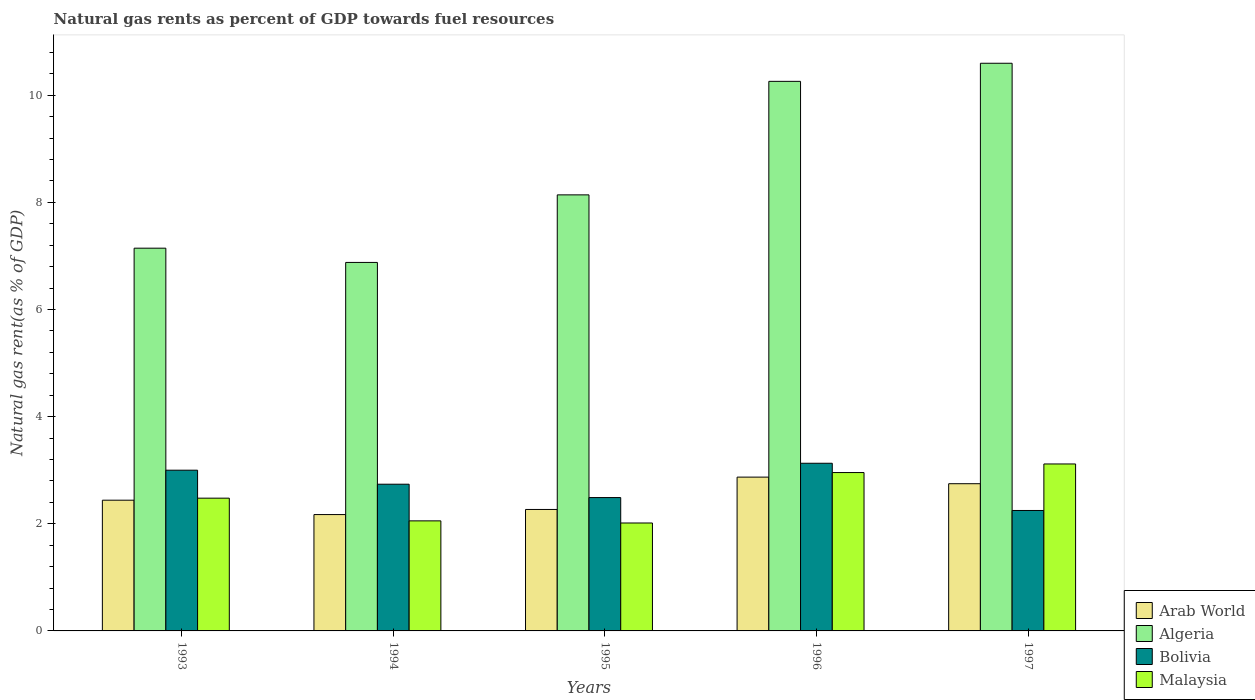How many bars are there on the 1st tick from the right?
Your answer should be very brief. 4. In how many cases, is the number of bars for a given year not equal to the number of legend labels?
Provide a succinct answer. 0. What is the natural gas rent in Arab World in 1996?
Keep it short and to the point. 2.87. Across all years, what is the maximum natural gas rent in Arab World?
Ensure brevity in your answer.  2.87. Across all years, what is the minimum natural gas rent in Algeria?
Your answer should be very brief. 6.88. In which year was the natural gas rent in Malaysia maximum?
Your response must be concise. 1997. In which year was the natural gas rent in Arab World minimum?
Your response must be concise. 1994. What is the total natural gas rent in Algeria in the graph?
Keep it short and to the point. 43.02. What is the difference between the natural gas rent in Arab World in 1993 and that in 1996?
Ensure brevity in your answer.  -0.43. What is the difference between the natural gas rent in Algeria in 1993 and the natural gas rent in Arab World in 1997?
Ensure brevity in your answer.  4.4. What is the average natural gas rent in Arab World per year?
Your answer should be very brief. 2.5. In the year 1996, what is the difference between the natural gas rent in Arab World and natural gas rent in Malaysia?
Your answer should be compact. -0.09. In how many years, is the natural gas rent in Malaysia greater than 4 %?
Your answer should be compact. 0. What is the ratio of the natural gas rent in Bolivia in 1994 to that in 1995?
Your answer should be very brief. 1.1. Is the natural gas rent in Malaysia in 1994 less than that in 1996?
Ensure brevity in your answer.  Yes. What is the difference between the highest and the second highest natural gas rent in Malaysia?
Your answer should be compact. 0.16. What is the difference between the highest and the lowest natural gas rent in Algeria?
Give a very brief answer. 3.72. In how many years, is the natural gas rent in Algeria greater than the average natural gas rent in Algeria taken over all years?
Your answer should be very brief. 2. Is the sum of the natural gas rent in Malaysia in 1995 and 1996 greater than the maximum natural gas rent in Algeria across all years?
Give a very brief answer. No. What does the 2nd bar from the right in 1995 represents?
Offer a very short reply. Bolivia. Is it the case that in every year, the sum of the natural gas rent in Bolivia and natural gas rent in Algeria is greater than the natural gas rent in Arab World?
Offer a very short reply. Yes. How many bars are there?
Offer a terse response. 20. How many years are there in the graph?
Keep it short and to the point. 5. Are the values on the major ticks of Y-axis written in scientific E-notation?
Offer a very short reply. No. Does the graph contain any zero values?
Ensure brevity in your answer.  No. Does the graph contain grids?
Provide a short and direct response. No. How are the legend labels stacked?
Your answer should be compact. Vertical. What is the title of the graph?
Give a very brief answer. Natural gas rents as percent of GDP towards fuel resources. Does "South Sudan" appear as one of the legend labels in the graph?
Ensure brevity in your answer.  No. What is the label or title of the X-axis?
Keep it short and to the point. Years. What is the label or title of the Y-axis?
Make the answer very short. Natural gas rent(as % of GDP). What is the Natural gas rent(as % of GDP) of Arab World in 1993?
Offer a terse response. 2.44. What is the Natural gas rent(as % of GDP) in Algeria in 1993?
Your answer should be compact. 7.15. What is the Natural gas rent(as % of GDP) of Bolivia in 1993?
Give a very brief answer. 3. What is the Natural gas rent(as % of GDP) of Malaysia in 1993?
Your response must be concise. 2.48. What is the Natural gas rent(as % of GDP) in Arab World in 1994?
Ensure brevity in your answer.  2.17. What is the Natural gas rent(as % of GDP) of Algeria in 1994?
Offer a terse response. 6.88. What is the Natural gas rent(as % of GDP) in Bolivia in 1994?
Your response must be concise. 2.74. What is the Natural gas rent(as % of GDP) of Malaysia in 1994?
Offer a very short reply. 2.05. What is the Natural gas rent(as % of GDP) in Arab World in 1995?
Ensure brevity in your answer.  2.27. What is the Natural gas rent(as % of GDP) of Algeria in 1995?
Your answer should be very brief. 8.14. What is the Natural gas rent(as % of GDP) of Bolivia in 1995?
Offer a terse response. 2.49. What is the Natural gas rent(as % of GDP) in Malaysia in 1995?
Your answer should be compact. 2.01. What is the Natural gas rent(as % of GDP) of Arab World in 1996?
Ensure brevity in your answer.  2.87. What is the Natural gas rent(as % of GDP) of Algeria in 1996?
Ensure brevity in your answer.  10.26. What is the Natural gas rent(as % of GDP) in Bolivia in 1996?
Offer a very short reply. 3.13. What is the Natural gas rent(as % of GDP) of Malaysia in 1996?
Offer a terse response. 2.96. What is the Natural gas rent(as % of GDP) of Arab World in 1997?
Provide a succinct answer. 2.75. What is the Natural gas rent(as % of GDP) of Algeria in 1997?
Make the answer very short. 10.6. What is the Natural gas rent(as % of GDP) of Bolivia in 1997?
Your answer should be very brief. 2.25. What is the Natural gas rent(as % of GDP) of Malaysia in 1997?
Your answer should be compact. 3.12. Across all years, what is the maximum Natural gas rent(as % of GDP) of Arab World?
Make the answer very short. 2.87. Across all years, what is the maximum Natural gas rent(as % of GDP) in Algeria?
Give a very brief answer. 10.6. Across all years, what is the maximum Natural gas rent(as % of GDP) of Bolivia?
Ensure brevity in your answer.  3.13. Across all years, what is the maximum Natural gas rent(as % of GDP) of Malaysia?
Offer a very short reply. 3.12. Across all years, what is the minimum Natural gas rent(as % of GDP) of Arab World?
Provide a succinct answer. 2.17. Across all years, what is the minimum Natural gas rent(as % of GDP) of Algeria?
Your answer should be compact. 6.88. Across all years, what is the minimum Natural gas rent(as % of GDP) in Bolivia?
Make the answer very short. 2.25. Across all years, what is the minimum Natural gas rent(as % of GDP) in Malaysia?
Give a very brief answer. 2.01. What is the total Natural gas rent(as % of GDP) in Arab World in the graph?
Ensure brevity in your answer.  12.5. What is the total Natural gas rent(as % of GDP) of Algeria in the graph?
Provide a succinct answer. 43.02. What is the total Natural gas rent(as % of GDP) in Bolivia in the graph?
Make the answer very short. 13.61. What is the total Natural gas rent(as % of GDP) of Malaysia in the graph?
Provide a succinct answer. 12.62. What is the difference between the Natural gas rent(as % of GDP) of Arab World in 1993 and that in 1994?
Your response must be concise. 0.27. What is the difference between the Natural gas rent(as % of GDP) in Algeria in 1993 and that in 1994?
Keep it short and to the point. 0.27. What is the difference between the Natural gas rent(as % of GDP) of Bolivia in 1993 and that in 1994?
Offer a terse response. 0.26. What is the difference between the Natural gas rent(as % of GDP) in Malaysia in 1993 and that in 1994?
Your response must be concise. 0.42. What is the difference between the Natural gas rent(as % of GDP) of Arab World in 1993 and that in 1995?
Provide a succinct answer. 0.17. What is the difference between the Natural gas rent(as % of GDP) in Algeria in 1993 and that in 1995?
Your answer should be very brief. -0.99. What is the difference between the Natural gas rent(as % of GDP) of Bolivia in 1993 and that in 1995?
Offer a terse response. 0.51. What is the difference between the Natural gas rent(as % of GDP) of Malaysia in 1993 and that in 1995?
Your response must be concise. 0.46. What is the difference between the Natural gas rent(as % of GDP) of Arab World in 1993 and that in 1996?
Offer a very short reply. -0.43. What is the difference between the Natural gas rent(as % of GDP) in Algeria in 1993 and that in 1996?
Make the answer very short. -3.11. What is the difference between the Natural gas rent(as % of GDP) of Bolivia in 1993 and that in 1996?
Your answer should be compact. -0.13. What is the difference between the Natural gas rent(as % of GDP) in Malaysia in 1993 and that in 1996?
Ensure brevity in your answer.  -0.48. What is the difference between the Natural gas rent(as % of GDP) of Arab World in 1993 and that in 1997?
Ensure brevity in your answer.  -0.31. What is the difference between the Natural gas rent(as % of GDP) of Algeria in 1993 and that in 1997?
Your answer should be compact. -3.45. What is the difference between the Natural gas rent(as % of GDP) of Bolivia in 1993 and that in 1997?
Make the answer very short. 0.75. What is the difference between the Natural gas rent(as % of GDP) in Malaysia in 1993 and that in 1997?
Provide a short and direct response. -0.64. What is the difference between the Natural gas rent(as % of GDP) in Arab World in 1994 and that in 1995?
Your response must be concise. -0.1. What is the difference between the Natural gas rent(as % of GDP) in Algeria in 1994 and that in 1995?
Provide a short and direct response. -1.26. What is the difference between the Natural gas rent(as % of GDP) of Bolivia in 1994 and that in 1995?
Offer a terse response. 0.25. What is the difference between the Natural gas rent(as % of GDP) in Malaysia in 1994 and that in 1995?
Provide a short and direct response. 0.04. What is the difference between the Natural gas rent(as % of GDP) in Arab World in 1994 and that in 1996?
Keep it short and to the point. -0.7. What is the difference between the Natural gas rent(as % of GDP) of Algeria in 1994 and that in 1996?
Your answer should be very brief. -3.38. What is the difference between the Natural gas rent(as % of GDP) of Bolivia in 1994 and that in 1996?
Make the answer very short. -0.39. What is the difference between the Natural gas rent(as % of GDP) of Malaysia in 1994 and that in 1996?
Your answer should be very brief. -0.9. What is the difference between the Natural gas rent(as % of GDP) of Arab World in 1994 and that in 1997?
Your answer should be compact. -0.58. What is the difference between the Natural gas rent(as % of GDP) of Algeria in 1994 and that in 1997?
Give a very brief answer. -3.72. What is the difference between the Natural gas rent(as % of GDP) of Bolivia in 1994 and that in 1997?
Your answer should be compact. 0.49. What is the difference between the Natural gas rent(as % of GDP) of Malaysia in 1994 and that in 1997?
Provide a short and direct response. -1.06. What is the difference between the Natural gas rent(as % of GDP) in Arab World in 1995 and that in 1996?
Provide a short and direct response. -0.6. What is the difference between the Natural gas rent(as % of GDP) in Algeria in 1995 and that in 1996?
Your answer should be compact. -2.12. What is the difference between the Natural gas rent(as % of GDP) in Bolivia in 1995 and that in 1996?
Keep it short and to the point. -0.64. What is the difference between the Natural gas rent(as % of GDP) of Malaysia in 1995 and that in 1996?
Ensure brevity in your answer.  -0.94. What is the difference between the Natural gas rent(as % of GDP) in Arab World in 1995 and that in 1997?
Your answer should be very brief. -0.48. What is the difference between the Natural gas rent(as % of GDP) of Algeria in 1995 and that in 1997?
Your answer should be compact. -2.46. What is the difference between the Natural gas rent(as % of GDP) in Bolivia in 1995 and that in 1997?
Your answer should be compact. 0.24. What is the difference between the Natural gas rent(as % of GDP) in Malaysia in 1995 and that in 1997?
Your answer should be compact. -1.1. What is the difference between the Natural gas rent(as % of GDP) in Arab World in 1996 and that in 1997?
Make the answer very short. 0.12. What is the difference between the Natural gas rent(as % of GDP) of Algeria in 1996 and that in 1997?
Provide a succinct answer. -0.34. What is the difference between the Natural gas rent(as % of GDP) of Bolivia in 1996 and that in 1997?
Your response must be concise. 0.88. What is the difference between the Natural gas rent(as % of GDP) of Malaysia in 1996 and that in 1997?
Offer a terse response. -0.16. What is the difference between the Natural gas rent(as % of GDP) in Arab World in 1993 and the Natural gas rent(as % of GDP) in Algeria in 1994?
Keep it short and to the point. -4.44. What is the difference between the Natural gas rent(as % of GDP) in Arab World in 1993 and the Natural gas rent(as % of GDP) in Bolivia in 1994?
Your answer should be very brief. -0.3. What is the difference between the Natural gas rent(as % of GDP) of Arab World in 1993 and the Natural gas rent(as % of GDP) of Malaysia in 1994?
Your answer should be compact. 0.39. What is the difference between the Natural gas rent(as % of GDP) of Algeria in 1993 and the Natural gas rent(as % of GDP) of Bolivia in 1994?
Offer a very short reply. 4.41. What is the difference between the Natural gas rent(as % of GDP) of Algeria in 1993 and the Natural gas rent(as % of GDP) of Malaysia in 1994?
Ensure brevity in your answer.  5.09. What is the difference between the Natural gas rent(as % of GDP) in Bolivia in 1993 and the Natural gas rent(as % of GDP) in Malaysia in 1994?
Offer a very short reply. 0.95. What is the difference between the Natural gas rent(as % of GDP) in Arab World in 1993 and the Natural gas rent(as % of GDP) in Algeria in 1995?
Your response must be concise. -5.7. What is the difference between the Natural gas rent(as % of GDP) of Arab World in 1993 and the Natural gas rent(as % of GDP) of Bolivia in 1995?
Ensure brevity in your answer.  -0.05. What is the difference between the Natural gas rent(as % of GDP) of Arab World in 1993 and the Natural gas rent(as % of GDP) of Malaysia in 1995?
Make the answer very short. 0.43. What is the difference between the Natural gas rent(as % of GDP) of Algeria in 1993 and the Natural gas rent(as % of GDP) of Bolivia in 1995?
Keep it short and to the point. 4.66. What is the difference between the Natural gas rent(as % of GDP) in Algeria in 1993 and the Natural gas rent(as % of GDP) in Malaysia in 1995?
Give a very brief answer. 5.13. What is the difference between the Natural gas rent(as % of GDP) in Bolivia in 1993 and the Natural gas rent(as % of GDP) in Malaysia in 1995?
Offer a very short reply. 0.99. What is the difference between the Natural gas rent(as % of GDP) in Arab World in 1993 and the Natural gas rent(as % of GDP) in Algeria in 1996?
Give a very brief answer. -7.82. What is the difference between the Natural gas rent(as % of GDP) of Arab World in 1993 and the Natural gas rent(as % of GDP) of Bolivia in 1996?
Give a very brief answer. -0.69. What is the difference between the Natural gas rent(as % of GDP) of Arab World in 1993 and the Natural gas rent(as % of GDP) of Malaysia in 1996?
Offer a terse response. -0.52. What is the difference between the Natural gas rent(as % of GDP) in Algeria in 1993 and the Natural gas rent(as % of GDP) in Bolivia in 1996?
Offer a terse response. 4.02. What is the difference between the Natural gas rent(as % of GDP) in Algeria in 1993 and the Natural gas rent(as % of GDP) in Malaysia in 1996?
Offer a very short reply. 4.19. What is the difference between the Natural gas rent(as % of GDP) in Bolivia in 1993 and the Natural gas rent(as % of GDP) in Malaysia in 1996?
Ensure brevity in your answer.  0.04. What is the difference between the Natural gas rent(as % of GDP) of Arab World in 1993 and the Natural gas rent(as % of GDP) of Algeria in 1997?
Make the answer very short. -8.16. What is the difference between the Natural gas rent(as % of GDP) in Arab World in 1993 and the Natural gas rent(as % of GDP) in Bolivia in 1997?
Provide a succinct answer. 0.19. What is the difference between the Natural gas rent(as % of GDP) of Arab World in 1993 and the Natural gas rent(as % of GDP) of Malaysia in 1997?
Make the answer very short. -0.68. What is the difference between the Natural gas rent(as % of GDP) in Algeria in 1993 and the Natural gas rent(as % of GDP) in Bolivia in 1997?
Keep it short and to the point. 4.9. What is the difference between the Natural gas rent(as % of GDP) of Algeria in 1993 and the Natural gas rent(as % of GDP) of Malaysia in 1997?
Keep it short and to the point. 4.03. What is the difference between the Natural gas rent(as % of GDP) of Bolivia in 1993 and the Natural gas rent(as % of GDP) of Malaysia in 1997?
Offer a terse response. -0.12. What is the difference between the Natural gas rent(as % of GDP) in Arab World in 1994 and the Natural gas rent(as % of GDP) in Algeria in 1995?
Keep it short and to the point. -5.97. What is the difference between the Natural gas rent(as % of GDP) of Arab World in 1994 and the Natural gas rent(as % of GDP) of Bolivia in 1995?
Keep it short and to the point. -0.32. What is the difference between the Natural gas rent(as % of GDP) in Arab World in 1994 and the Natural gas rent(as % of GDP) in Malaysia in 1995?
Your answer should be compact. 0.16. What is the difference between the Natural gas rent(as % of GDP) of Algeria in 1994 and the Natural gas rent(as % of GDP) of Bolivia in 1995?
Provide a succinct answer. 4.39. What is the difference between the Natural gas rent(as % of GDP) of Algeria in 1994 and the Natural gas rent(as % of GDP) of Malaysia in 1995?
Offer a very short reply. 4.86. What is the difference between the Natural gas rent(as % of GDP) in Bolivia in 1994 and the Natural gas rent(as % of GDP) in Malaysia in 1995?
Keep it short and to the point. 0.72. What is the difference between the Natural gas rent(as % of GDP) of Arab World in 1994 and the Natural gas rent(as % of GDP) of Algeria in 1996?
Your response must be concise. -8.09. What is the difference between the Natural gas rent(as % of GDP) in Arab World in 1994 and the Natural gas rent(as % of GDP) in Bolivia in 1996?
Your answer should be very brief. -0.96. What is the difference between the Natural gas rent(as % of GDP) of Arab World in 1994 and the Natural gas rent(as % of GDP) of Malaysia in 1996?
Your answer should be compact. -0.78. What is the difference between the Natural gas rent(as % of GDP) in Algeria in 1994 and the Natural gas rent(as % of GDP) in Bolivia in 1996?
Offer a terse response. 3.75. What is the difference between the Natural gas rent(as % of GDP) of Algeria in 1994 and the Natural gas rent(as % of GDP) of Malaysia in 1996?
Give a very brief answer. 3.92. What is the difference between the Natural gas rent(as % of GDP) of Bolivia in 1994 and the Natural gas rent(as % of GDP) of Malaysia in 1996?
Provide a short and direct response. -0.22. What is the difference between the Natural gas rent(as % of GDP) in Arab World in 1994 and the Natural gas rent(as % of GDP) in Algeria in 1997?
Your answer should be compact. -8.43. What is the difference between the Natural gas rent(as % of GDP) of Arab World in 1994 and the Natural gas rent(as % of GDP) of Bolivia in 1997?
Keep it short and to the point. -0.08. What is the difference between the Natural gas rent(as % of GDP) of Arab World in 1994 and the Natural gas rent(as % of GDP) of Malaysia in 1997?
Give a very brief answer. -0.94. What is the difference between the Natural gas rent(as % of GDP) of Algeria in 1994 and the Natural gas rent(as % of GDP) of Bolivia in 1997?
Provide a short and direct response. 4.63. What is the difference between the Natural gas rent(as % of GDP) in Algeria in 1994 and the Natural gas rent(as % of GDP) in Malaysia in 1997?
Your answer should be very brief. 3.76. What is the difference between the Natural gas rent(as % of GDP) in Bolivia in 1994 and the Natural gas rent(as % of GDP) in Malaysia in 1997?
Ensure brevity in your answer.  -0.38. What is the difference between the Natural gas rent(as % of GDP) of Arab World in 1995 and the Natural gas rent(as % of GDP) of Algeria in 1996?
Offer a very short reply. -7.99. What is the difference between the Natural gas rent(as % of GDP) of Arab World in 1995 and the Natural gas rent(as % of GDP) of Bolivia in 1996?
Your response must be concise. -0.86. What is the difference between the Natural gas rent(as % of GDP) of Arab World in 1995 and the Natural gas rent(as % of GDP) of Malaysia in 1996?
Provide a short and direct response. -0.69. What is the difference between the Natural gas rent(as % of GDP) in Algeria in 1995 and the Natural gas rent(as % of GDP) in Bolivia in 1996?
Make the answer very short. 5.01. What is the difference between the Natural gas rent(as % of GDP) in Algeria in 1995 and the Natural gas rent(as % of GDP) in Malaysia in 1996?
Make the answer very short. 5.18. What is the difference between the Natural gas rent(as % of GDP) in Bolivia in 1995 and the Natural gas rent(as % of GDP) in Malaysia in 1996?
Offer a very short reply. -0.47. What is the difference between the Natural gas rent(as % of GDP) in Arab World in 1995 and the Natural gas rent(as % of GDP) in Algeria in 1997?
Give a very brief answer. -8.33. What is the difference between the Natural gas rent(as % of GDP) in Arab World in 1995 and the Natural gas rent(as % of GDP) in Bolivia in 1997?
Your response must be concise. 0.02. What is the difference between the Natural gas rent(as % of GDP) of Arab World in 1995 and the Natural gas rent(as % of GDP) of Malaysia in 1997?
Your response must be concise. -0.85. What is the difference between the Natural gas rent(as % of GDP) in Algeria in 1995 and the Natural gas rent(as % of GDP) in Bolivia in 1997?
Your answer should be compact. 5.89. What is the difference between the Natural gas rent(as % of GDP) of Algeria in 1995 and the Natural gas rent(as % of GDP) of Malaysia in 1997?
Keep it short and to the point. 5.02. What is the difference between the Natural gas rent(as % of GDP) of Bolivia in 1995 and the Natural gas rent(as % of GDP) of Malaysia in 1997?
Provide a succinct answer. -0.63. What is the difference between the Natural gas rent(as % of GDP) in Arab World in 1996 and the Natural gas rent(as % of GDP) in Algeria in 1997?
Offer a very short reply. -7.73. What is the difference between the Natural gas rent(as % of GDP) of Arab World in 1996 and the Natural gas rent(as % of GDP) of Bolivia in 1997?
Your answer should be very brief. 0.62. What is the difference between the Natural gas rent(as % of GDP) in Arab World in 1996 and the Natural gas rent(as % of GDP) in Malaysia in 1997?
Your answer should be very brief. -0.25. What is the difference between the Natural gas rent(as % of GDP) in Algeria in 1996 and the Natural gas rent(as % of GDP) in Bolivia in 1997?
Your answer should be compact. 8.01. What is the difference between the Natural gas rent(as % of GDP) in Algeria in 1996 and the Natural gas rent(as % of GDP) in Malaysia in 1997?
Provide a short and direct response. 7.14. What is the difference between the Natural gas rent(as % of GDP) of Bolivia in 1996 and the Natural gas rent(as % of GDP) of Malaysia in 1997?
Your answer should be compact. 0.01. What is the average Natural gas rent(as % of GDP) of Arab World per year?
Ensure brevity in your answer.  2.5. What is the average Natural gas rent(as % of GDP) in Algeria per year?
Provide a succinct answer. 8.6. What is the average Natural gas rent(as % of GDP) in Bolivia per year?
Make the answer very short. 2.72. What is the average Natural gas rent(as % of GDP) in Malaysia per year?
Offer a very short reply. 2.52. In the year 1993, what is the difference between the Natural gas rent(as % of GDP) of Arab World and Natural gas rent(as % of GDP) of Algeria?
Give a very brief answer. -4.7. In the year 1993, what is the difference between the Natural gas rent(as % of GDP) in Arab World and Natural gas rent(as % of GDP) in Bolivia?
Provide a succinct answer. -0.56. In the year 1993, what is the difference between the Natural gas rent(as % of GDP) of Arab World and Natural gas rent(as % of GDP) of Malaysia?
Give a very brief answer. -0.04. In the year 1993, what is the difference between the Natural gas rent(as % of GDP) in Algeria and Natural gas rent(as % of GDP) in Bolivia?
Give a very brief answer. 4.14. In the year 1993, what is the difference between the Natural gas rent(as % of GDP) in Algeria and Natural gas rent(as % of GDP) in Malaysia?
Provide a short and direct response. 4.67. In the year 1993, what is the difference between the Natural gas rent(as % of GDP) of Bolivia and Natural gas rent(as % of GDP) of Malaysia?
Provide a succinct answer. 0.52. In the year 1994, what is the difference between the Natural gas rent(as % of GDP) of Arab World and Natural gas rent(as % of GDP) of Algeria?
Provide a succinct answer. -4.71. In the year 1994, what is the difference between the Natural gas rent(as % of GDP) in Arab World and Natural gas rent(as % of GDP) in Bolivia?
Offer a very short reply. -0.57. In the year 1994, what is the difference between the Natural gas rent(as % of GDP) in Arab World and Natural gas rent(as % of GDP) in Malaysia?
Ensure brevity in your answer.  0.12. In the year 1994, what is the difference between the Natural gas rent(as % of GDP) in Algeria and Natural gas rent(as % of GDP) in Bolivia?
Offer a very short reply. 4.14. In the year 1994, what is the difference between the Natural gas rent(as % of GDP) in Algeria and Natural gas rent(as % of GDP) in Malaysia?
Give a very brief answer. 4.82. In the year 1994, what is the difference between the Natural gas rent(as % of GDP) of Bolivia and Natural gas rent(as % of GDP) of Malaysia?
Offer a very short reply. 0.68. In the year 1995, what is the difference between the Natural gas rent(as % of GDP) in Arab World and Natural gas rent(as % of GDP) in Algeria?
Keep it short and to the point. -5.87. In the year 1995, what is the difference between the Natural gas rent(as % of GDP) of Arab World and Natural gas rent(as % of GDP) of Bolivia?
Your response must be concise. -0.22. In the year 1995, what is the difference between the Natural gas rent(as % of GDP) in Arab World and Natural gas rent(as % of GDP) in Malaysia?
Offer a terse response. 0.25. In the year 1995, what is the difference between the Natural gas rent(as % of GDP) in Algeria and Natural gas rent(as % of GDP) in Bolivia?
Provide a succinct answer. 5.65. In the year 1995, what is the difference between the Natural gas rent(as % of GDP) of Algeria and Natural gas rent(as % of GDP) of Malaysia?
Provide a succinct answer. 6.13. In the year 1995, what is the difference between the Natural gas rent(as % of GDP) of Bolivia and Natural gas rent(as % of GDP) of Malaysia?
Give a very brief answer. 0.47. In the year 1996, what is the difference between the Natural gas rent(as % of GDP) of Arab World and Natural gas rent(as % of GDP) of Algeria?
Your response must be concise. -7.39. In the year 1996, what is the difference between the Natural gas rent(as % of GDP) of Arab World and Natural gas rent(as % of GDP) of Bolivia?
Your response must be concise. -0.26. In the year 1996, what is the difference between the Natural gas rent(as % of GDP) of Arab World and Natural gas rent(as % of GDP) of Malaysia?
Ensure brevity in your answer.  -0.09. In the year 1996, what is the difference between the Natural gas rent(as % of GDP) of Algeria and Natural gas rent(as % of GDP) of Bolivia?
Your response must be concise. 7.13. In the year 1996, what is the difference between the Natural gas rent(as % of GDP) in Algeria and Natural gas rent(as % of GDP) in Malaysia?
Keep it short and to the point. 7.3. In the year 1996, what is the difference between the Natural gas rent(as % of GDP) in Bolivia and Natural gas rent(as % of GDP) in Malaysia?
Offer a very short reply. 0.17. In the year 1997, what is the difference between the Natural gas rent(as % of GDP) of Arab World and Natural gas rent(as % of GDP) of Algeria?
Ensure brevity in your answer.  -7.85. In the year 1997, what is the difference between the Natural gas rent(as % of GDP) in Arab World and Natural gas rent(as % of GDP) in Bolivia?
Keep it short and to the point. 0.5. In the year 1997, what is the difference between the Natural gas rent(as % of GDP) of Arab World and Natural gas rent(as % of GDP) of Malaysia?
Give a very brief answer. -0.37. In the year 1997, what is the difference between the Natural gas rent(as % of GDP) in Algeria and Natural gas rent(as % of GDP) in Bolivia?
Provide a succinct answer. 8.35. In the year 1997, what is the difference between the Natural gas rent(as % of GDP) in Algeria and Natural gas rent(as % of GDP) in Malaysia?
Provide a short and direct response. 7.48. In the year 1997, what is the difference between the Natural gas rent(as % of GDP) of Bolivia and Natural gas rent(as % of GDP) of Malaysia?
Your answer should be very brief. -0.87. What is the ratio of the Natural gas rent(as % of GDP) of Arab World in 1993 to that in 1994?
Make the answer very short. 1.12. What is the ratio of the Natural gas rent(as % of GDP) in Algeria in 1993 to that in 1994?
Your response must be concise. 1.04. What is the ratio of the Natural gas rent(as % of GDP) of Bolivia in 1993 to that in 1994?
Give a very brief answer. 1.1. What is the ratio of the Natural gas rent(as % of GDP) in Malaysia in 1993 to that in 1994?
Make the answer very short. 1.21. What is the ratio of the Natural gas rent(as % of GDP) of Arab World in 1993 to that in 1995?
Your answer should be compact. 1.08. What is the ratio of the Natural gas rent(as % of GDP) of Algeria in 1993 to that in 1995?
Your answer should be compact. 0.88. What is the ratio of the Natural gas rent(as % of GDP) in Bolivia in 1993 to that in 1995?
Keep it short and to the point. 1.21. What is the ratio of the Natural gas rent(as % of GDP) of Malaysia in 1993 to that in 1995?
Your answer should be compact. 1.23. What is the ratio of the Natural gas rent(as % of GDP) of Arab World in 1993 to that in 1996?
Offer a very short reply. 0.85. What is the ratio of the Natural gas rent(as % of GDP) in Algeria in 1993 to that in 1996?
Your answer should be compact. 0.7. What is the ratio of the Natural gas rent(as % of GDP) in Bolivia in 1993 to that in 1996?
Provide a short and direct response. 0.96. What is the ratio of the Natural gas rent(as % of GDP) in Malaysia in 1993 to that in 1996?
Your answer should be very brief. 0.84. What is the ratio of the Natural gas rent(as % of GDP) in Arab World in 1993 to that in 1997?
Your response must be concise. 0.89. What is the ratio of the Natural gas rent(as % of GDP) in Algeria in 1993 to that in 1997?
Ensure brevity in your answer.  0.67. What is the ratio of the Natural gas rent(as % of GDP) in Bolivia in 1993 to that in 1997?
Keep it short and to the point. 1.33. What is the ratio of the Natural gas rent(as % of GDP) in Malaysia in 1993 to that in 1997?
Provide a short and direct response. 0.8. What is the ratio of the Natural gas rent(as % of GDP) of Arab World in 1994 to that in 1995?
Make the answer very short. 0.96. What is the ratio of the Natural gas rent(as % of GDP) of Algeria in 1994 to that in 1995?
Offer a very short reply. 0.85. What is the ratio of the Natural gas rent(as % of GDP) in Bolivia in 1994 to that in 1995?
Your answer should be very brief. 1.1. What is the ratio of the Natural gas rent(as % of GDP) of Malaysia in 1994 to that in 1995?
Your response must be concise. 1.02. What is the ratio of the Natural gas rent(as % of GDP) in Arab World in 1994 to that in 1996?
Provide a succinct answer. 0.76. What is the ratio of the Natural gas rent(as % of GDP) in Algeria in 1994 to that in 1996?
Your answer should be very brief. 0.67. What is the ratio of the Natural gas rent(as % of GDP) in Bolivia in 1994 to that in 1996?
Provide a short and direct response. 0.88. What is the ratio of the Natural gas rent(as % of GDP) of Malaysia in 1994 to that in 1996?
Give a very brief answer. 0.69. What is the ratio of the Natural gas rent(as % of GDP) of Arab World in 1994 to that in 1997?
Your answer should be compact. 0.79. What is the ratio of the Natural gas rent(as % of GDP) of Algeria in 1994 to that in 1997?
Your answer should be very brief. 0.65. What is the ratio of the Natural gas rent(as % of GDP) in Bolivia in 1994 to that in 1997?
Offer a terse response. 1.22. What is the ratio of the Natural gas rent(as % of GDP) in Malaysia in 1994 to that in 1997?
Your answer should be compact. 0.66. What is the ratio of the Natural gas rent(as % of GDP) of Arab World in 1995 to that in 1996?
Give a very brief answer. 0.79. What is the ratio of the Natural gas rent(as % of GDP) in Algeria in 1995 to that in 1996?
Your answer should be compact. 0.79. What is the ratio of the Natural gas rent(as % of GDP) of Bolivia in 1995 to that in 1996?
Offer a terse response. 0.8. What is the ratio of the Natural gas rent(as % of GDP) of Malaysia in 1995 to that in 1996?
Your answer should be compact. 0.68. What is the ratio of the Natural gas rent(as % of GDP) of Arab World in 1995 to that in 1997?
Offer a very short reply. 0.82. What is the ratio of the Natural gas rent(as % of GDP) of Algeria in 1995 to that in 1997?
Ensure brevity in your answer.  0.77. What is the ratio of the Natural gas rent(as % of GDP) in Bolivia in 1995 to that in 1997?
Offer a very short reply. 1.11. What is the ratio of the Natural gas rent(as % of GDP) of Malaysia in 1995 to that in 1997?
Make the answer very short. 0.65. What is the ratio of the Natural gas rent(as % of GDP) in Arab World in 1996 to that in 1997?
Give a very brief answer. 1.04. What is the ratio of the Natural gas rent(as % of GDP) in Algeria in 1996 to that in 1997?
Your answer should be compact. 0.97. What is the ratio of the Natural gas rent(as % of GDP) of Bolivia in 1996 to that in 1997?
Your answer should be very brief. 1.39. What is the ratio of the Natural gas rent(as % of GDP) of Malaysia in 1996 to that in 1997?
Your answer should be compact. 0.95. What is the difference between the highest and the second highest Natural gas rent(as % of GDP) of Arab World?
Offer a very short reply. 0.12. What is the difference between the highest and the second highest Natural gas rent(as % of GDP) in Algeria?
Provide a succinct answer. 0.34. What is the difference between the highest and the second highest Natural gas rent(as % of GDP) of Bolivia?
Your response must be concise. 0.13. What is the difference between the highest and the second highest Natural gas rent(as % of GDP) in Malaysia?
Provide a succinct answer. 0.16. What is the difference between the highest and the lowest Natural gas rent(as % of GDP) of Arab World?
Provide a succinct answer. 0.7. What is the difference between the highest and the lowest Natural gas rent(as % of GDP) in Algeria?
Give a very brief answer. 3.72. What is the difference between the highest and the lowest Natural gas rent(as % of GDP) in Bolivia?
Keep it short and to the point. 0.88. What is the difference between the highest and the lowest Natural gas rent(as % of GDP) in Malaysia?
Your answer should be compact. 1.1. 